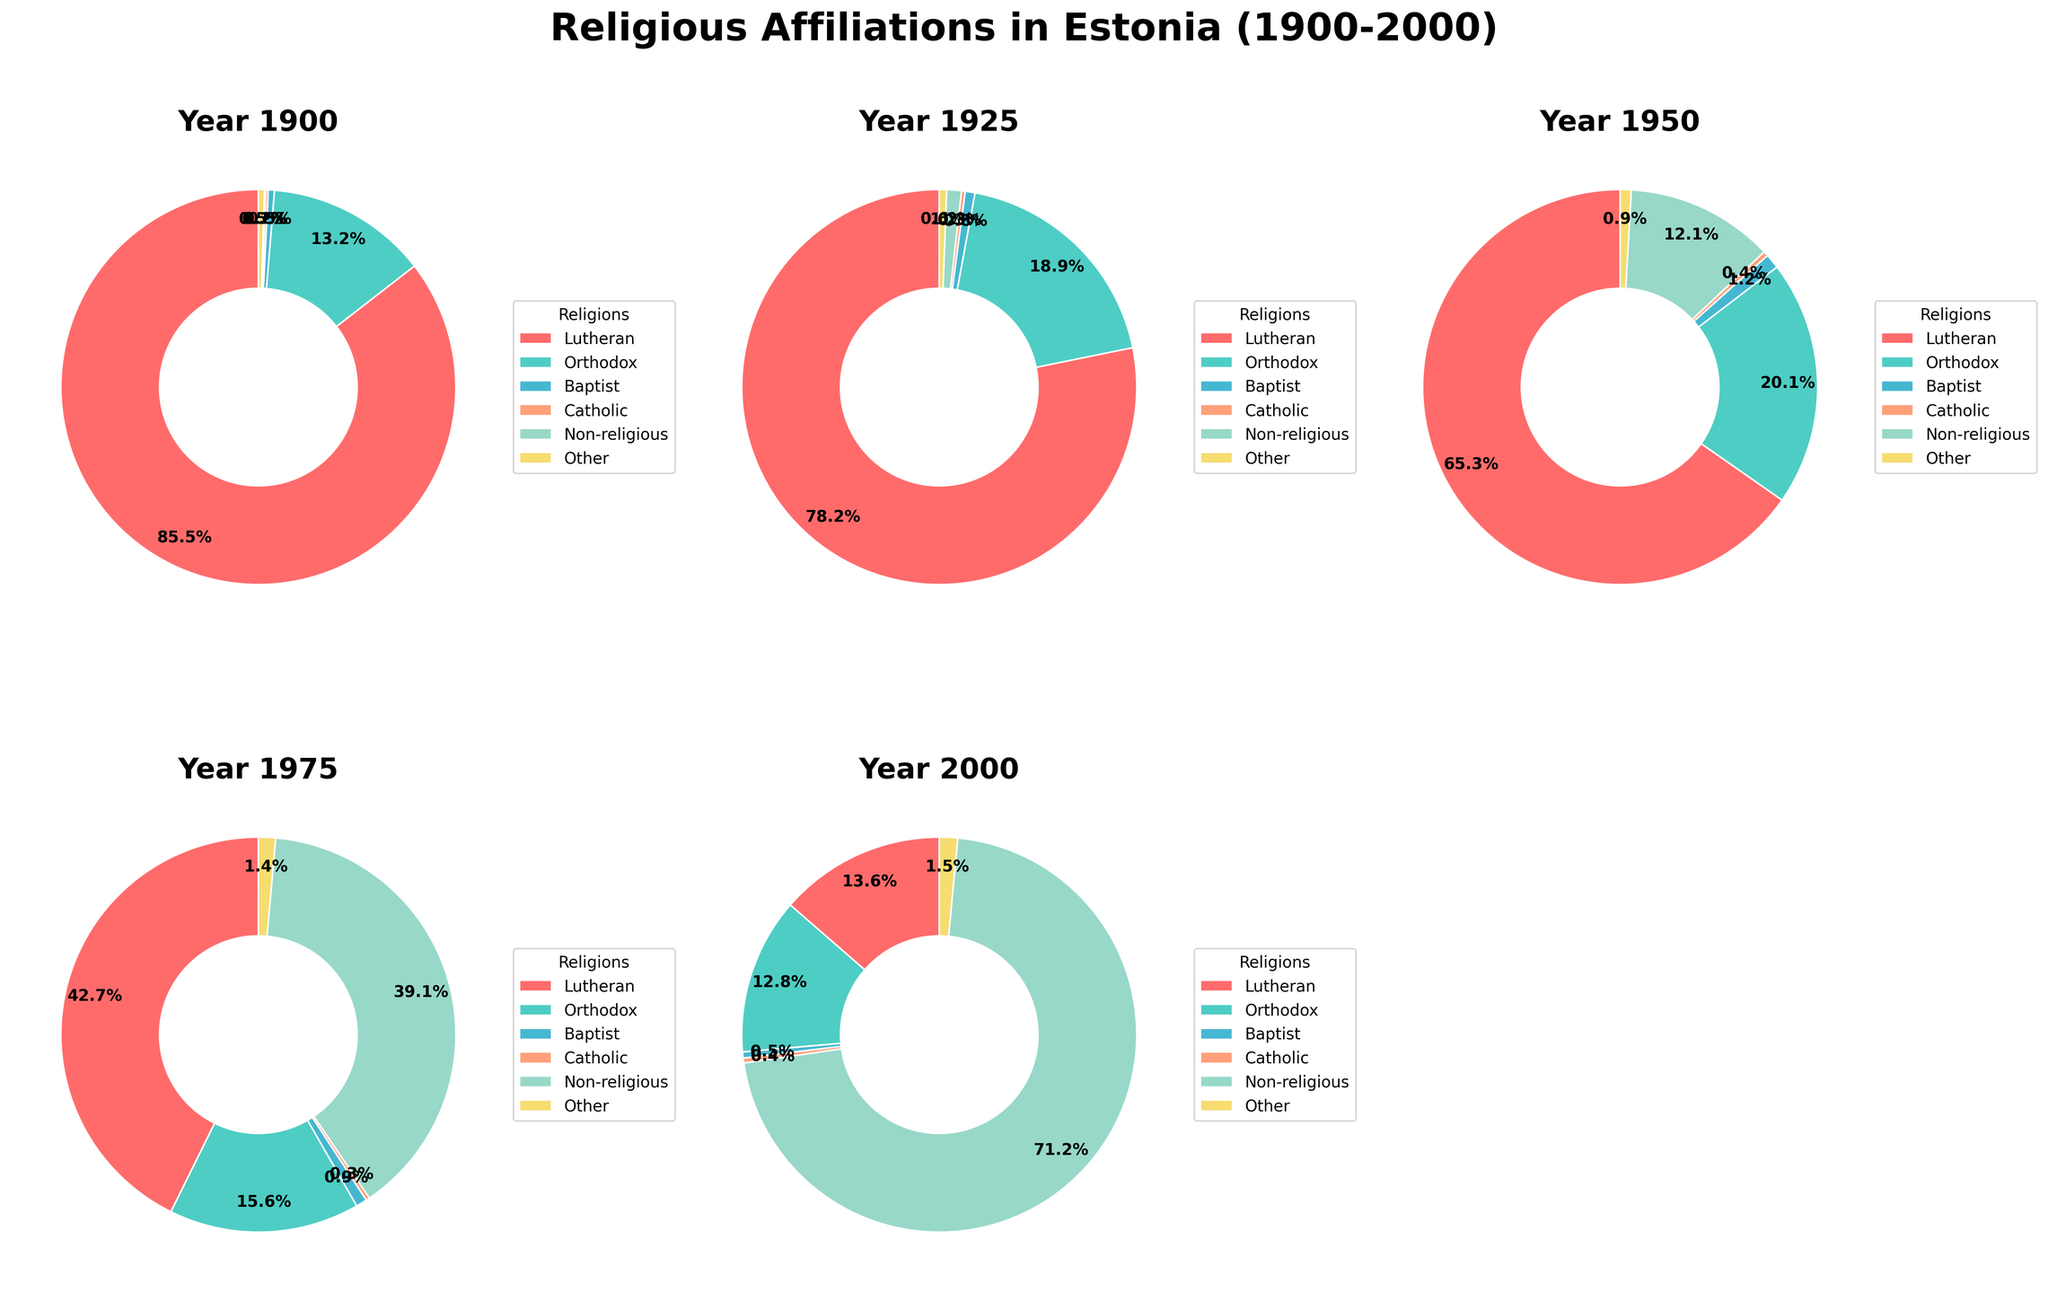What's the most predominant religious affiliation in Estonia in 1900? The pie chart for the year 1900 shows that the largest section (in red) represents Lutheranism with 85.5%.
Answer: Lutheranism Which religious affiliation sees the largest percentage increase from 1925 to 1950? Calculate the percentage increase for each affiliation: Lutheran -12.9%, Orthodox +1.2%, Baptist +0.4%, Catholic +0.1%, Non-religious +10.9%, Other +0.3%. The non-religious group increases the most from 1.2% to 12.1%.
Answer: Non-religious How does the percentage of the Orthodox population change from 1950 to 2000? Compare the Orthodox percentages: 1950 (20.1%), 2000 (12.8%). The percentage decreased by 7.3%.
Answer: It decreases Which year has the highest percentage of 'Non-religious' population? Look at the 'Non-religious' sections in each pie chart. The largest percentage is in the year 2000 with 71.2%.
Answer: 2000 Is the percentage of Lutherans greater than the percentage of Non-religious individuals in 1975? Compare the percentages for Lutherans (42.7%) and Non-religious (39.1%) in 1975. Lutherans have a slightly higher percentage.
Answer: Yes What religious affiliation is depicted in green color in all the pie charts? The color green consistently represents the Orthodox affiliation across all the pie charts.
Answer: Orthodox From 1900 to 2000, how does the relative share of the 'Other' religious affiliation change overall? Compare the 'Other' percentages: 1900 (0.5%), 1925 (0.6%), 1950 (0.9%), 1975 (1.4%), 2000 (1.5%). There is a gradual increase in the share over time.
Answer: It increases What is the combined percentage of Catholics and Baptists in 1950? Sum the percentages of Catholics (0.4%) and Baptists (1.2%) for the year 1950. The total is 1.6%.
Answer: 1.6% 